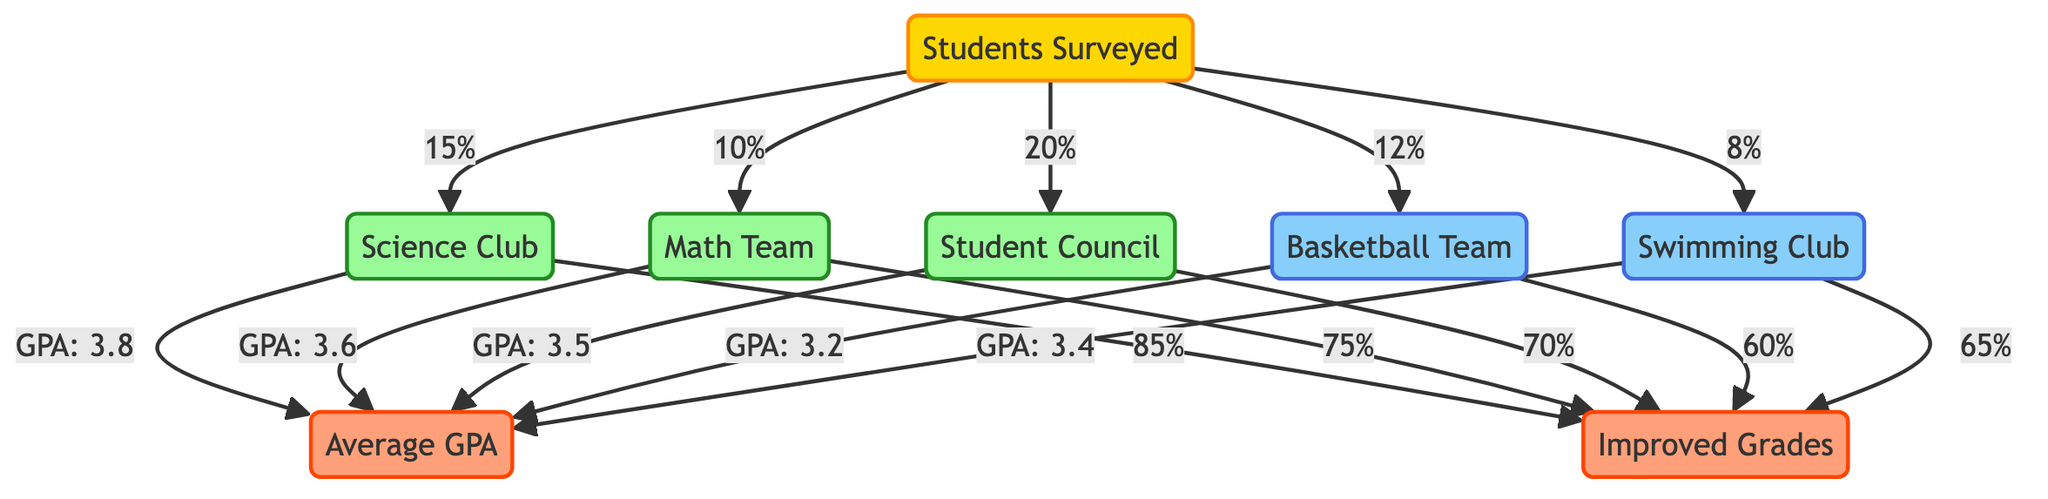What percentage of students are in the Swimming Club? From the diagram, the node labeled "Swimming Club" is connected to the "Students Surveyed" node with a flow indicating 8%. This means that 8% of surveyed students are part of the Swimming Club.
Answer: 8% What is the GPA of students in the Science Club? The "Science Club" node leads directly to the "Average GPA" node with a label indicating that students in this club have a GPA of 3.8. Thus, the GPA for Science Club members is 3.8.
Answer: 3.8 Which extracurricular activity has the highest percentage of improved grades? The "Improved Grades" outcome is linked with all activities. The Science Club has the highest percentage of improved grades at 85%, as indicated in its connection to the outcome node.
Answer: 85% How many clubs and sports are represented in the diagram? The diagram includes two types of nodes: activities and sports. There are three activities (Science Club, Math Team, Student Council) and two sports (Basketball Team, Swimming Club), totaling five.
Answer: 5 What does the GPA of Math Team members indicate about their academic performance? The Math Team has a GPA of 3.6, which shows that their performance is above average compared to the overall GPA obtained from various activities. It illustrates a positive correlation between participation in this extracurricular and academic achievement.
Answer: 3.6 Which activity has the lowest GPA among those surveyed? The "Basketball Team" node shows an affiliation with a GPA of 3.2, making it the lowest among the listed extracurricular activities in the diagram.
Answer: 3.2 What percentage of Student Council members reported improved grades? The "Student Council" activity connects to the "Improved Grades" node showing a flow of 70%. Thus, 70% of Student Council members reported improvements.
Answer: 70% What is the average GPA for students involved in sports? There are two sports represented: the "Basketball Team" with a GPA of 3.2 and the "Swimming Club" with a GPA of 3.4. The average GPA can be calculated as (3.2 + 3.4) / 2 = 3.3. Therefore, the average GPA for students involved in sports is 3.3.
Answer: 3.3 